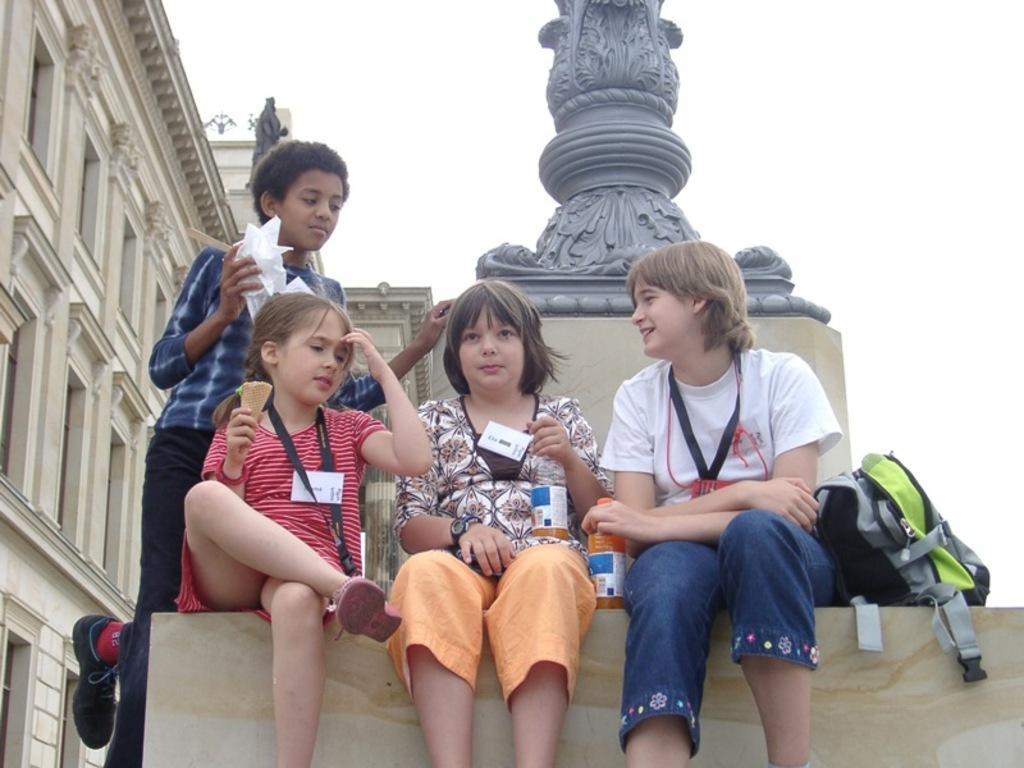Can you describe this image briefly? In the foreground of this image, there are three girls sitting on the slab of a statue. On the slab, there is a bottle and a bag. One girl is holding a cone of an ice cream and another girl is holding a bottle. there is a boy standing on the slab and holding tissues. On the left, there is a building and on the top, there is the sky. 